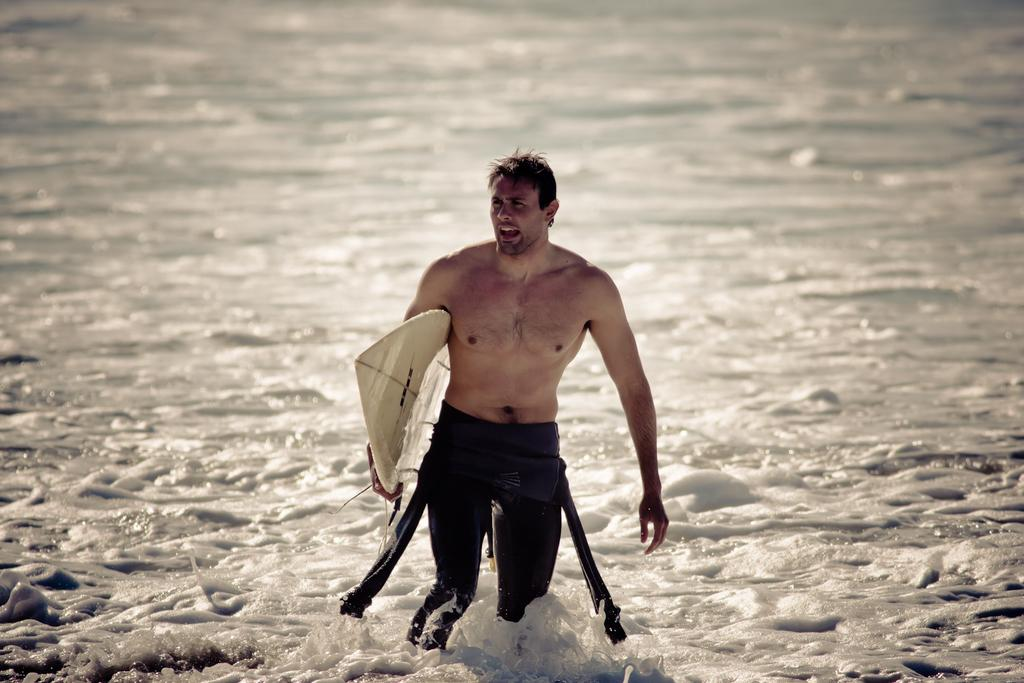Who is present in the image? There is a man in the image. What is the man doing in the image? The man is walking in the water. What object is the man holding in the image? The man is holding a surfboard in his hand. What type of feather can be seen on the man's hat in the image? There is no hat or feather present in the image; the man is holding a surfboard and walking in the water. 